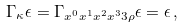<formula> <loc_0><loc_0><loc_500><loc_500>\Gamma _ { \kappa } \epsilon = \Gamma _ { x ^ { 0 } x ^ { 1 } x ^ { 2 } x ^ { 3 } 3 \rho } \epsilon = \epsilon \, ,</formula> 